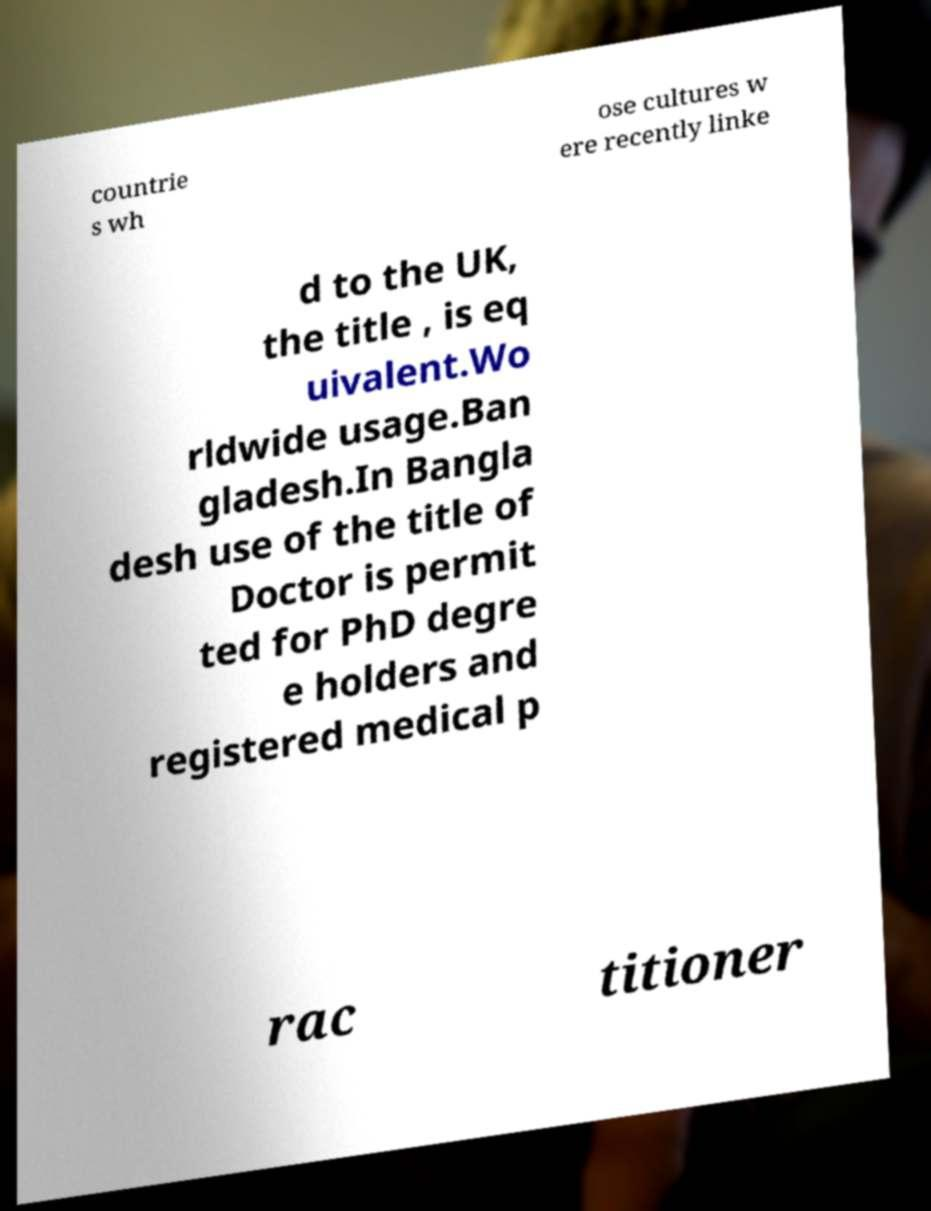For documentation purposes, I need the text within this image transcribed. Could you provide that? countrie s wh ose cultures w ere recently linke d to the UK, the title , is eq uivalent.Wo rldwide usage.Ban gladesh.In Bangla desh use of the title of Doctor is permit ted for PhD degre e holders and registered medical p rac titioner 